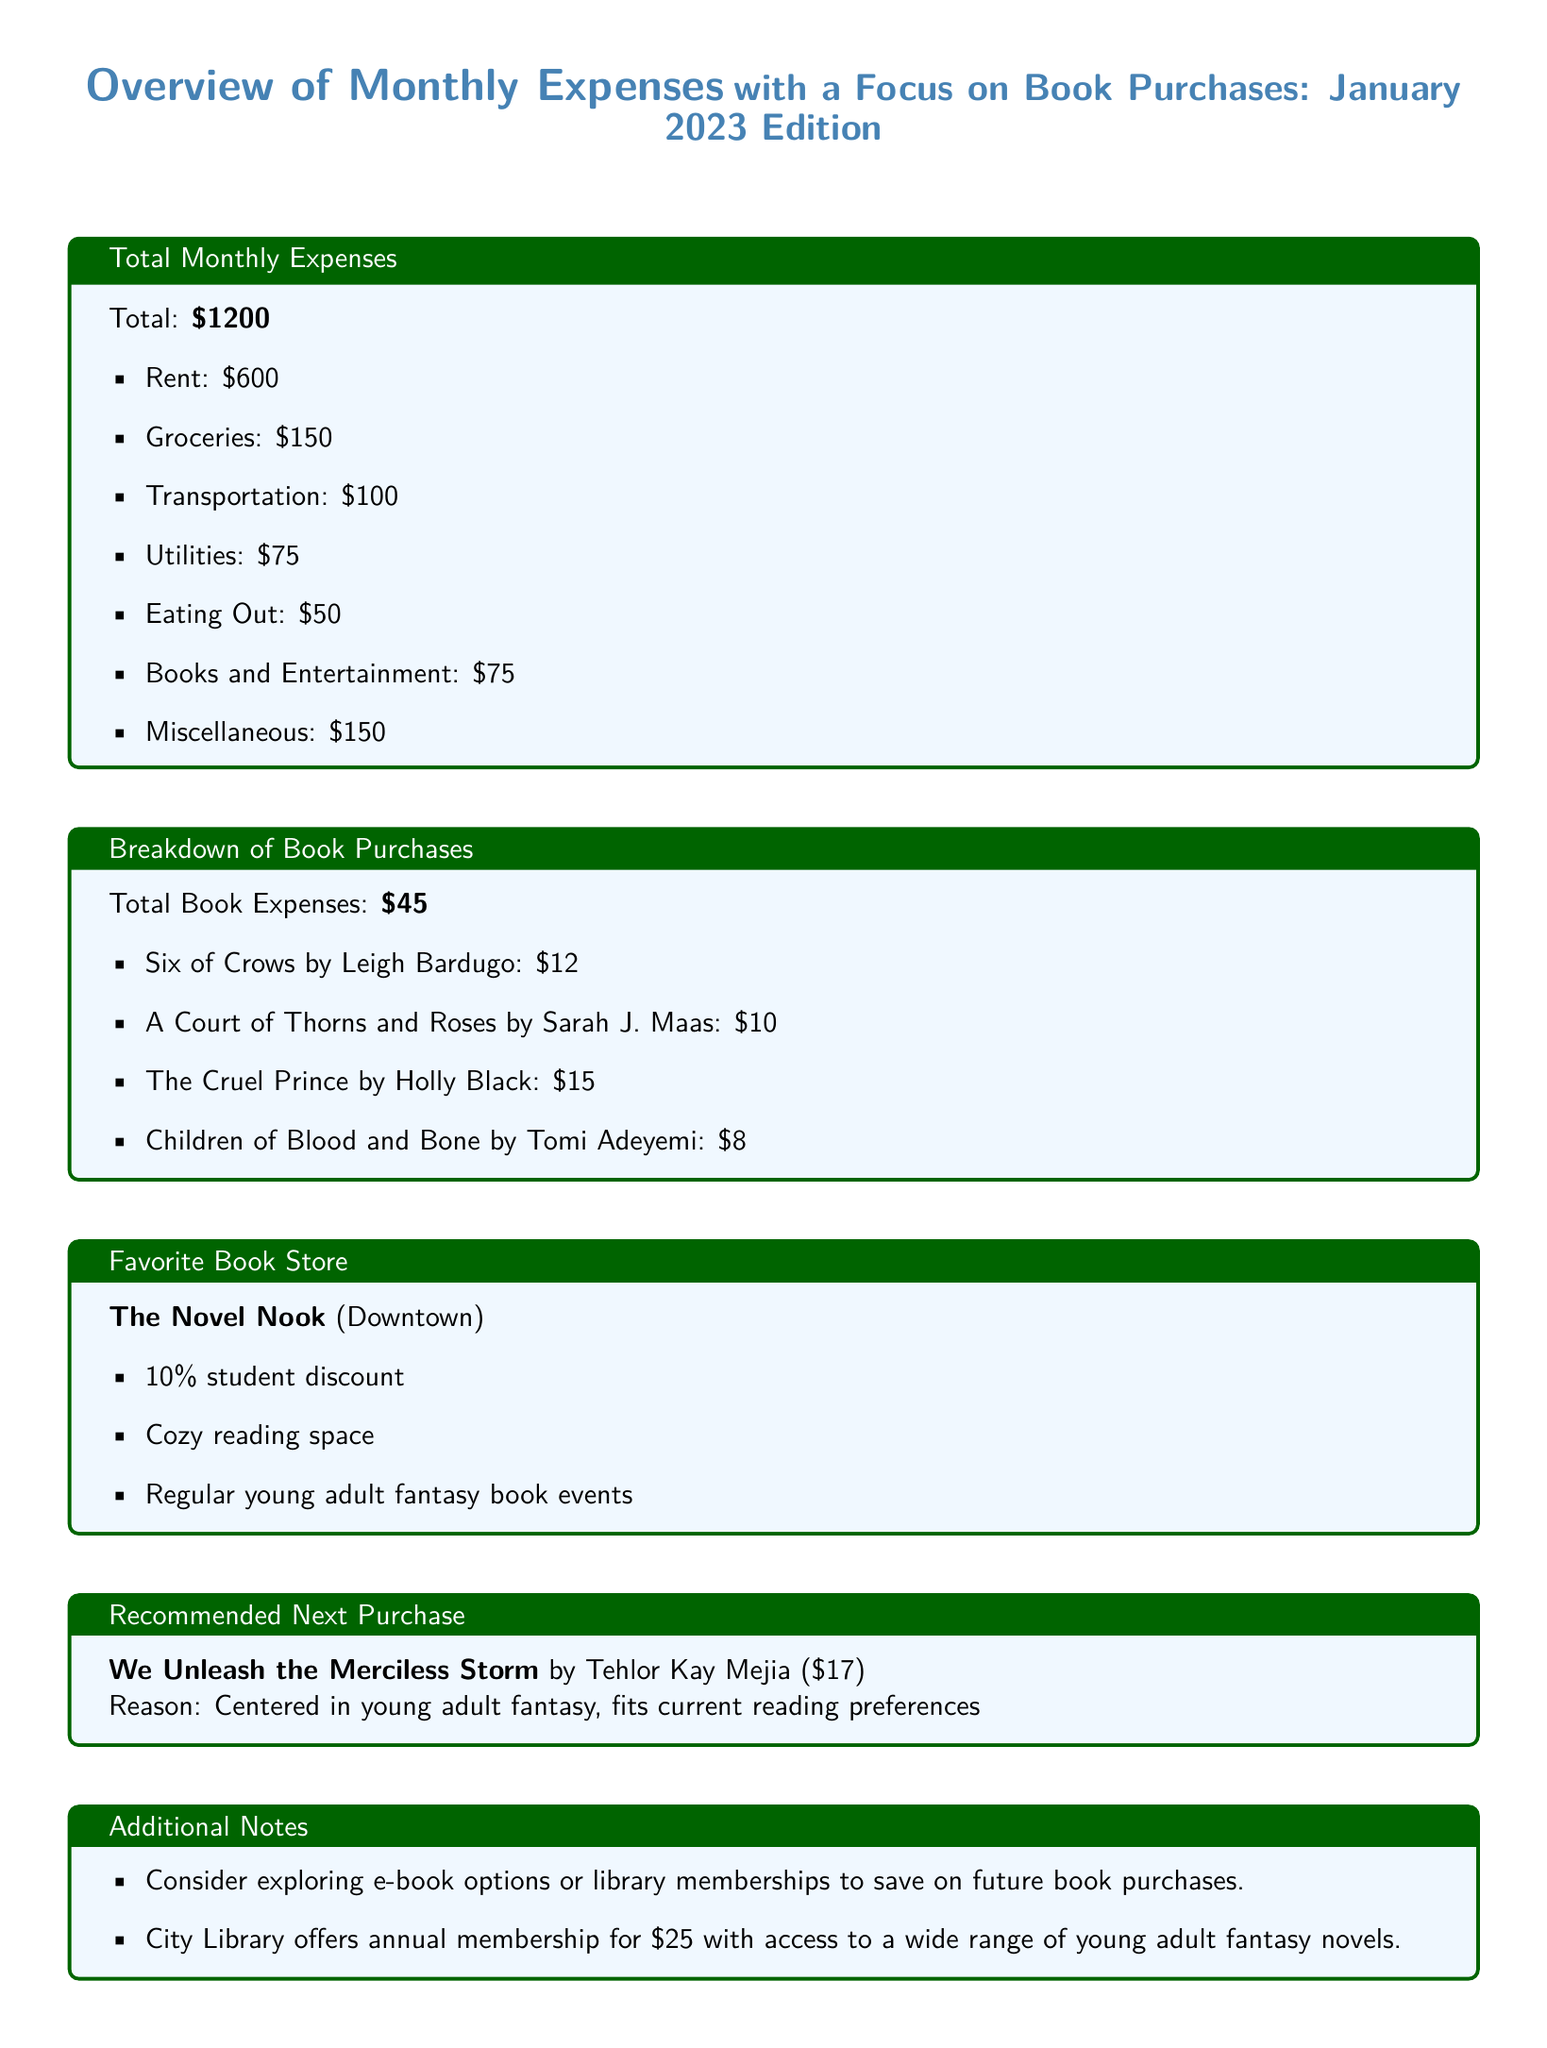What is the total monthly expense? The total monthly expense is stated in the document and equals $1200.
Answer: $1200 How much is spent on book purchases? The document specifies the total book expenses as $45.
Answer: $45 What is the name of the favorite book store? The favorite book store mentioned in the document is The Novel Nook.
Answer: The Novel Nook How much is the student discount at The Novel Nook? The document indicates a 10% student discount at The Novel Nook.
Answer: 10% What is the price of "We Unleash the Merciless Storm"? The price of "We Unleash the Merciless Storm" is listed in the document as $17.
Answer: $17 Which book has the highest purchase price? The document lists The Cruel Prince as the most expensive book at $15.
Answer: The Cruel Prince What additional option does the document suggest for saving on book purchases? The document suggests exploring e-book options or library memberships to save on future purchases.
Answer: e-book options or library memberships How much does the City Library's annual membership cost? The City Library's annual membership is mentioned in the document as $25.
Answer: $25 What type of books does The Novel Nook focus on? The document notes that The Novel Nook regularly holds young adult fantasy book events.
Answer: Young adult fantasy 